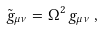Convert formula to latex. <formula><loc_0><loc_0><loc_500><loc_500>\tilde { g } _ { \mu \nu } = \Omega ^ { 2 } \, g _ { \mu \nu } \, ,</formula> 